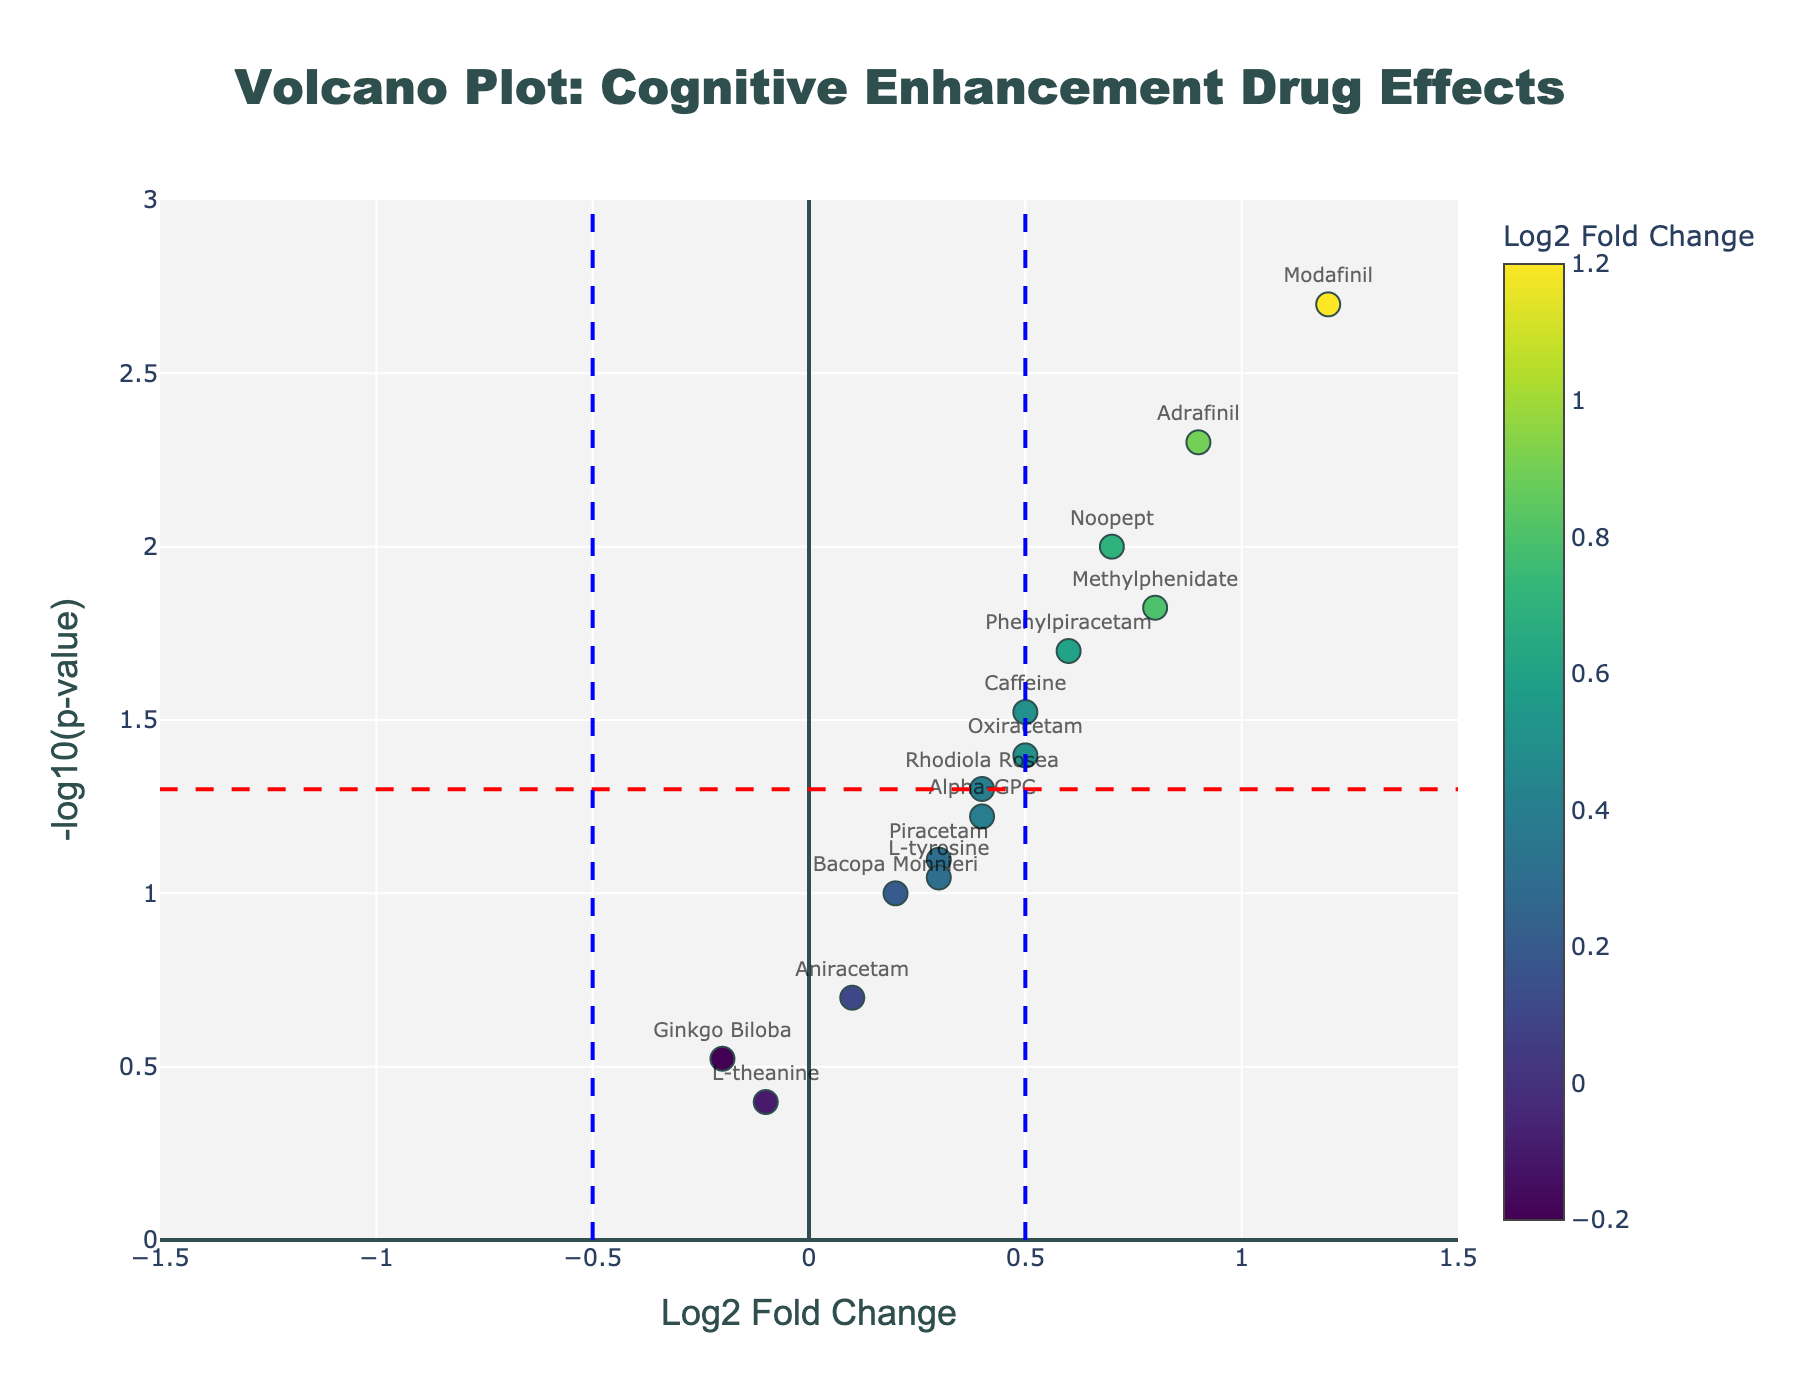how many drugs have a p-value less than 0.05? To determine the number of drugs with a p-value less than 0.05, look at the y-axis values (-log10(p-value)) of each marker. Values above approximately 1.3 correspond to p-values less than 0.05. Count the markers above this threshold. There are 7 markers above 1.3.
Answer: 7 Which drug has the highest Log2 Fold Change? Check the x-axis, which represents Log2 Fold Change. Identify the marker furthest to the right for the maximum Log2 Fold Change. The rightmost marker corresponds to Modafinil.
Answer: Modafinil What is the Log2 Fold Change and p-value of Adrafinil? Hover over the Adrafinil marker or locate its position on the plot, which lies at approximately (0.9, 2.3). The Log2 Fold Change appears to be 0.9, and the p-value is inferred using the -log10(p-value) position, which converts approximately to 0.005.
Answer: Log2FC: 0.9, p-value: 0.005 Which drugs have a p-value between 0.01 and 0.05? Identify the markers positioned between y-axis values -log10(0.01) (which is 2) and -log10(0.05) (which is approximately 1.3). The markers within this range are Noopept, Phenylpiracetam, Oxiracetam, and Rhodiola Rosea.
Answer: Noopept, Phenylpiracetam, Oxiracetam, Rhodiola Rosea What is the y-axis value for Methylphenidate and what does it represent? Locate the Methylphenidate marker and find its y-axis value, which is approximately 1.82. This y-axis value represents -log10(p-value).
Answer: 1.82 (representing -log10(p-value)) Which drugs have a negative Log2 Fold Change? Check the x-axis (Log2 Fold Change) values and identify markers to the left of zero (negative values). The drugs with negative Log2 Fold Change values are L-theanine and Ginkgo Biloba.
Answer: L-theanine, Ginkgo Biloba What is the approximate p-value for drugs with a -log10(p-value) of around 3? Find the markers with y-axis values around 3. Using the formula -log10(p-value) to p-value, we get p-value = 10^(-3), which is approximately 0.001.
Answer: 0.001 What is the relationship between Log2 Fold Change and the significance of the p-value in this plot? A higher Log2 Fold Change generally indicates a more significant effect. In this plot, points further to the right or left (higher absolute Log2 Fold Change) can be associated with lower p-values (more significant) if they also have higher y-axis values (-log10(p-value)).
Answer: Higher Log2 Fold Change, generally lower p-value How many drugs have both Log2 Fold Change greater than 0.5 and p-value less than 0.05? Identify drugs with Log2 Fold Change greater than 0.5 (right of the x=0.5 line) and then count those also above the y=1.3 line for -log10(p-value). These drugs are Modafinil, Adrafinil, Phenylpiracetam.
Answer: 3 